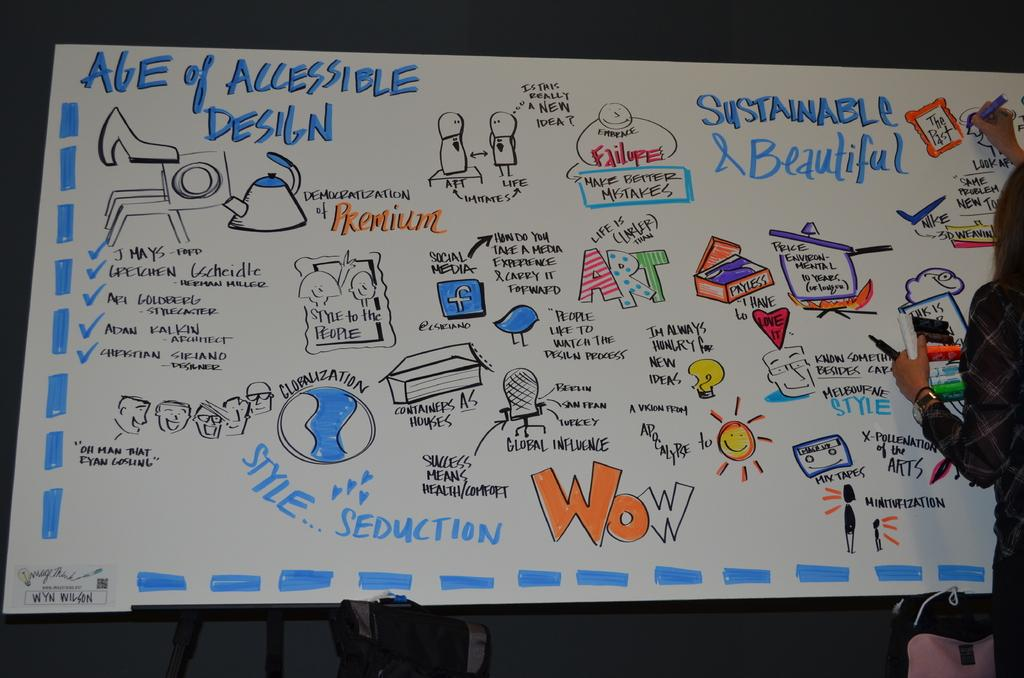What type of visual elements can be seen in the image? There are diagrams in the image. What other information is present in the image besides the diagrams? There is text on a chart in the image. What activity is the woman on the right side of the image engaged in? The woman is drawing a picture on the right side of the image. What type of fuel is being used by the woman to draw the picture? There is no mention of fuel in the image, as the woman is using a drawing instrument, not a fuel-powered device. 